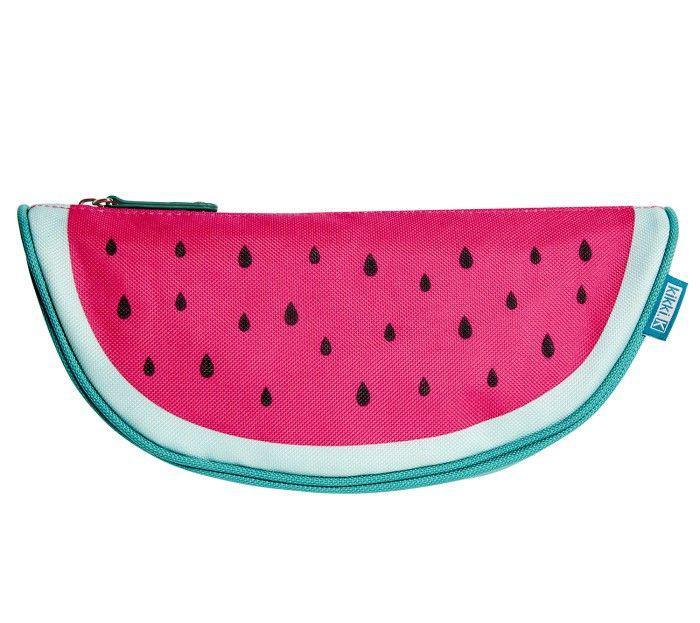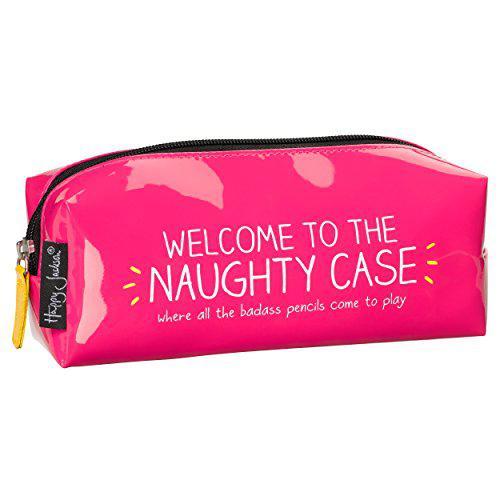The first image is the image on the left, the second image is the image on the right. Assess this claim about the two images: "The bag in the image on the left is shaped like a watermelon.". Correct or not? Answer yes or no. Yes. The first image is the image on the left, the second image is the image on the right. Examine the images to the left and right. Is the description "One of the cases looks like a watermelon slice with a turquoise-blue rind." accurate? Answer yes or no. Yes. 